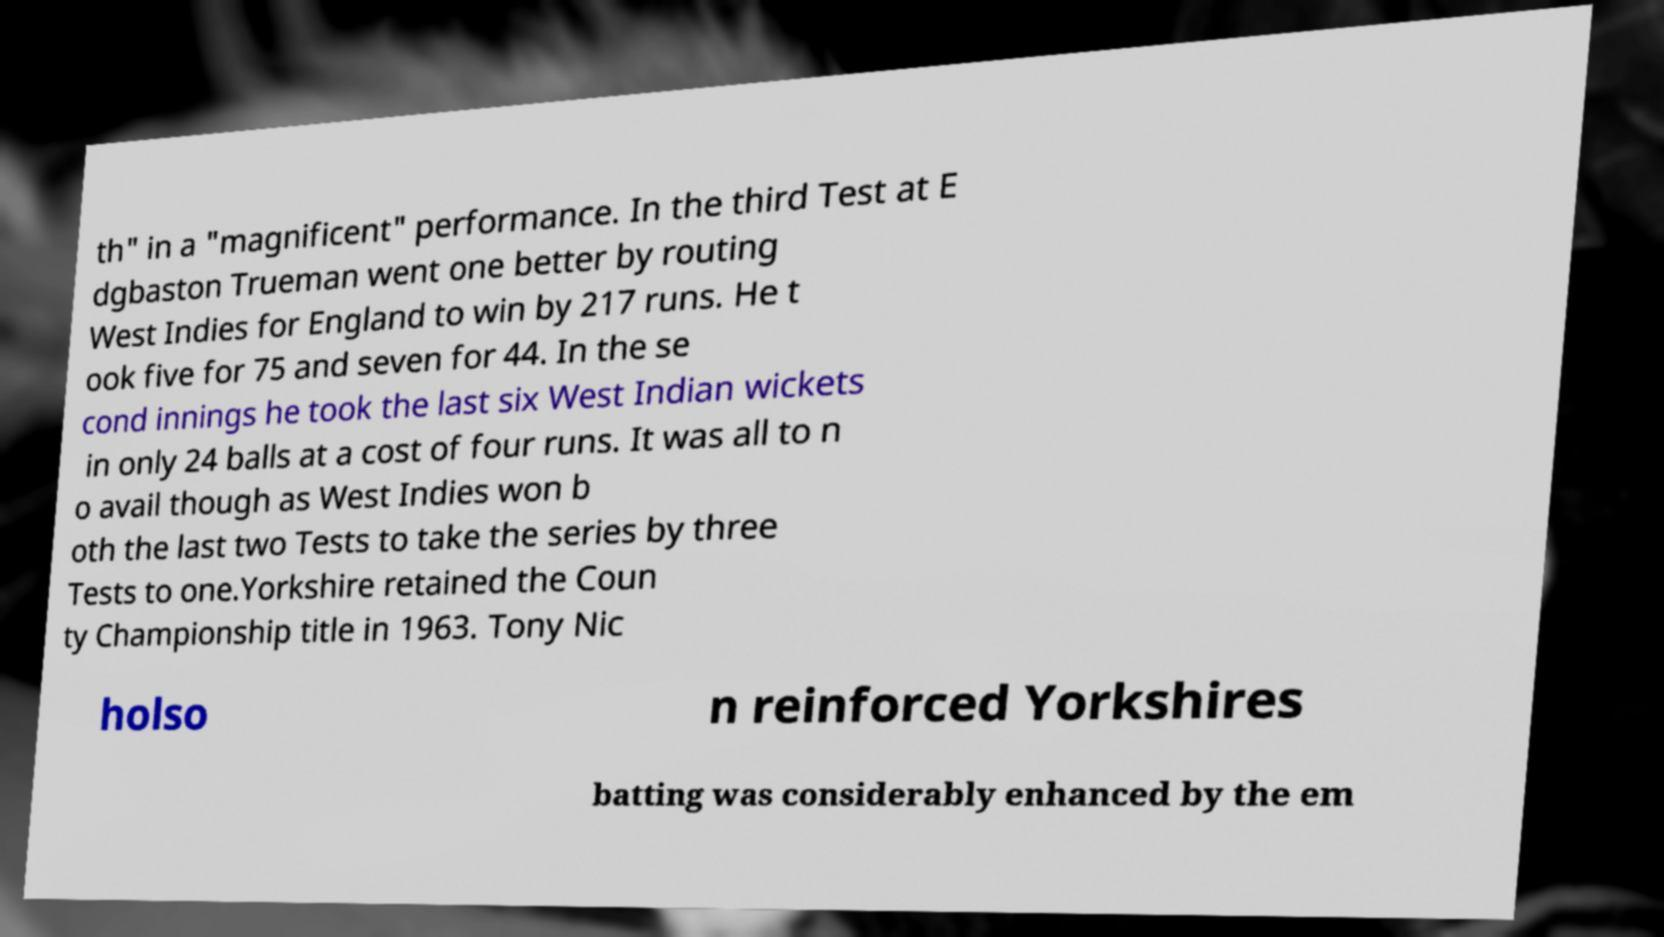Please read and relay the text visible in this image. What does it say? th" in a "magnificent" performance. In the third Test at E dgbaston Trueman went one better by routing West Indies for England to win by 217 runs. He t ook five for 75 and seven for 44. In the se cond innings he took the last six West Indian wickets in only 24 balls at a cost of four runs. It was all to n o avail though as West Indies won b oth the last two Tests to take the series by three Tests to one.Yorkshire retained the Coun ty Championship title in 1963. Tony Nic holso n reinforced Yorkshires batting was considerably enhanced by the em 